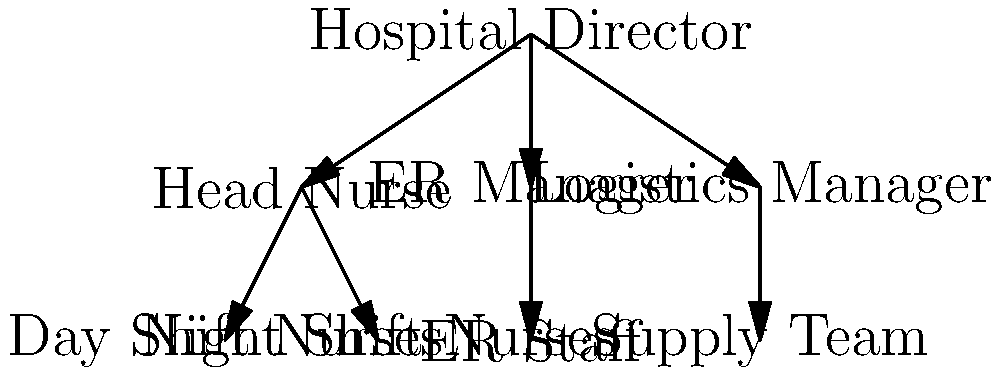Based on the organizational chart shown, which position is directly responsible for managing both the Day Shift Nurses and Night Shift Nurses? To answer this question, we need to analyze the hierarchical structure presented in the organizational chart:

1. At the top of the chart, we see the Hospital Director position.
2. Directly below the Hospital Director, there are three positions: Head Nurse, ER Manager, and Logistics Manager.
3. Under the Head Nurse position, we can see two groups: Day Shift Nurses and Night Shift Nurses.
4. The lines connecting these positions indicate reporting relationships.
5. We can observe that both Day Shift Nurses and Night Shift Nurses have lines connecting them to the Head Nurse position.
6. This direct connection implies that the Head Nurse is responsible for managing both groups of nurses.

Therefore, based on the organizational structure presented in the chart, the Head Nurse is the position directly responsible for managing both the Day Shift Nurses and Night Shift Nurses.
Answer: Head Nurse 